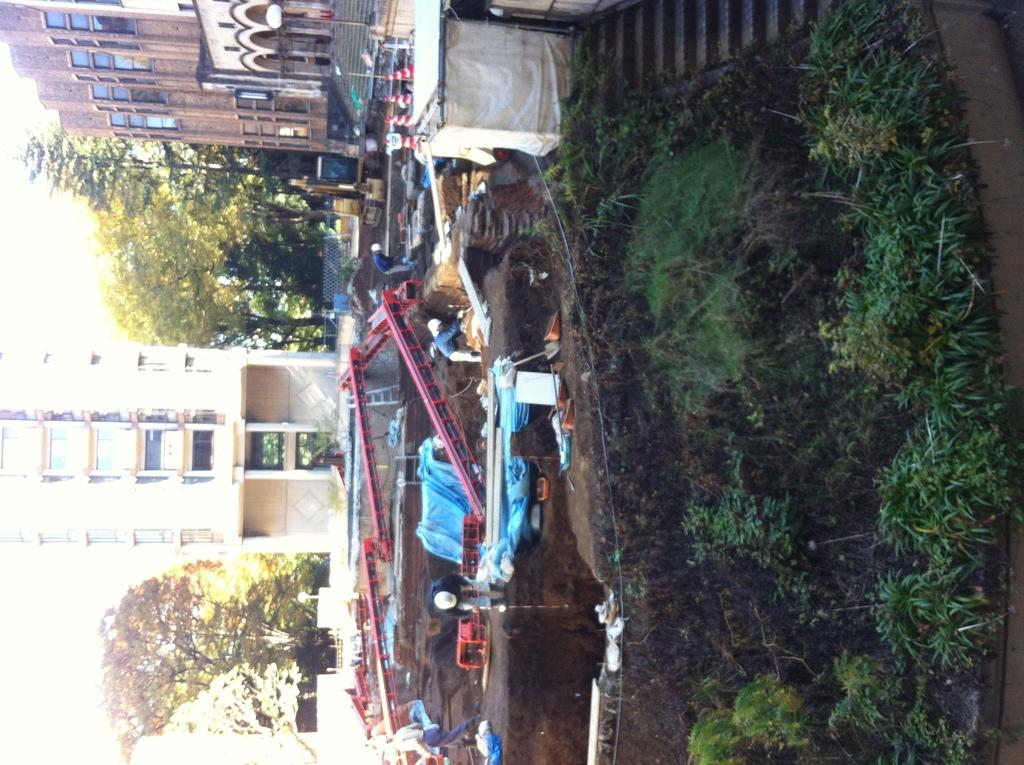What is the main subject of the image? The main subject of the image is an excavation in the middle of the image. What can be seen in the background of the image? In the background of the image, there are traffic cones, buildings, trees, the sky, plants, a staircase, and grass. What might be used to direct traffic in the image? Traffic cones can be seen in the background of the image, which might be used to direct traffic. Can you tell me how many kites are flying in the image? There are no kites visible in the image. What type of credit is being offered at the excavation site? There is no mention of credit or any financial transactions in the image. 